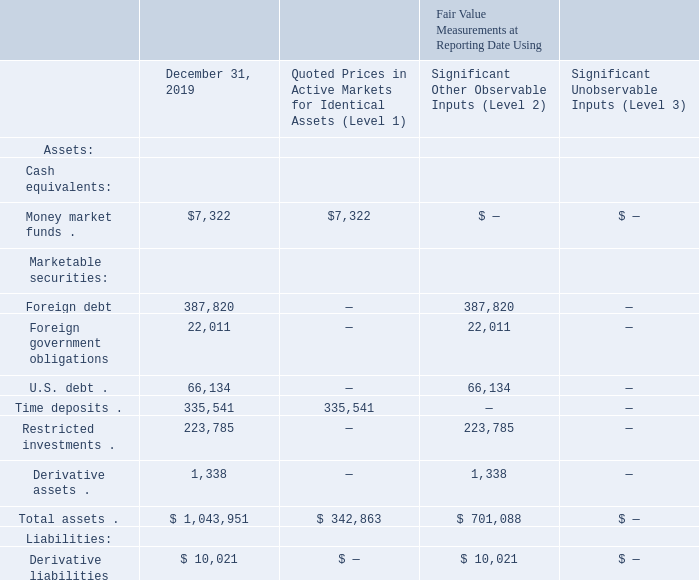11. Fair Value Measurements
The following is a description of the valuation techniques that we use to measure the fair value of assets and liabilities that we measure and report at fair value on a recurring basis:
Cash Equivalents. At December 31, 2019 and 2018, our cash equivalents consisted of money market funds. We value our cash equivalents using observable inputs that reflect quoted prices for securities with identical characteristics, and accordingly, we classify the valuation techniques that use these inputs as Level 1.
Marketable Securities and Restricted Investments. At December 31, 2019 and 2018, our marketable securities consisted of foreign debt, foreign government obligations, U.S. debt, and time deposits, and our restricted investments consisted of foreign and U.S. government obligations. We value our marketable securities and restricted investments using observable inputs that reflect quoted prices for securities with identical characteristics or quoted prices for securities with similar characteristics and other observable inputs (such as interest rates that are observable at commonly quoted intervals). Accordingly, we classify the valuation techniques that use these inputs as either Level 1 or Level 2 depending on the inputs used. We also consider the effect of our counterparties’ credit standing in these fair value measurements.
Derivative Assets and Liabilities. At December 31, 2019 and 2018, our derivative assets and liabilities consisted of foreign exchange forward contracts involving major currencies and interest rate swap contracts involving major interest rates. Since our derivative assets and liabilities are not traded on an exchange, we value them using standard industry valuation models. As applicable, these models project future cash flows and discount the amounts to a present value using market-based observable inputs, including interest rate curves, credit risk, foreign exchange rates, and forward and spot prices for currencies. These inputs are observable in active markets over the contract term of the derivative instruments we hold, and accordingly, we classify the valuation techniques as Level 2. In evaluating credit risk, we consider the effect of our counterparties’ and our own credit standing in the fair value measurements of our derivative assets and liabilities, respectively.
At December 31, 2019 and 2018, the fair value measurements of our assets and liabilities measured on a recurring basis were as follows (in thousands):
What is the value of money market funds as of December 31, 2019?
Answer scale should be: thousand. $7,322. What is the value of foreign debt as of December 31, 2019?
Answer scale should be: thousand. 387,820. What is the value of foreign government obligations as of December 31, 2019?
Answer scale should be: thousand. 22,011. What is the difference in the value of money market funds and foreign debt as of December 31, 2019?
Answer scale should be: thousand. 387,820-7,322
Answer: 380498. What is the percentage constitution of money market funds among the total assets as of December 31, 2019?
Answer scale should be: percent. 7,322/1,043,951
Answer: 0.7. What is the difference in the value of time deposits and restricted investments as of December 31, 2019?
Answer scale should be: thousand. 335,541-223,785
Answer: 111756. 